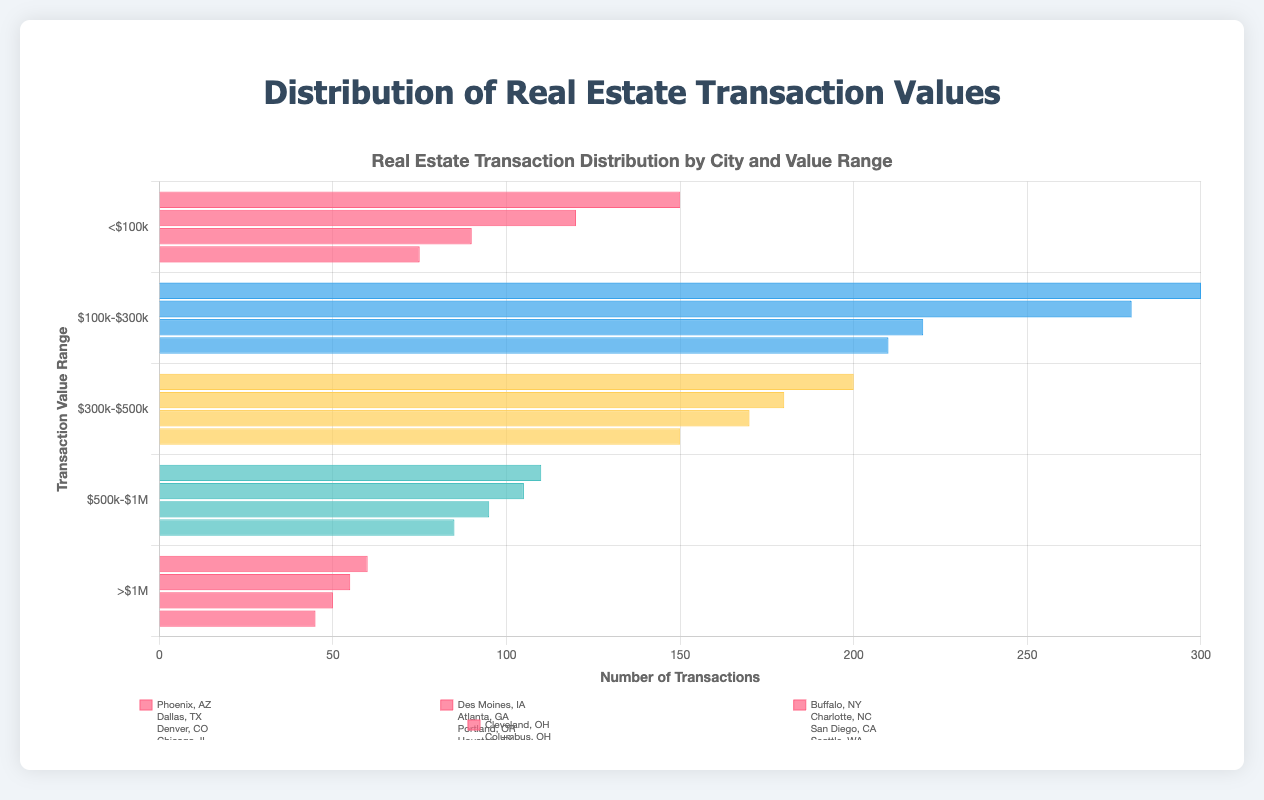Which city has the highest number of transactions in the <$100k range? Look at the first bar segment in each city category that corresponds to the <$100k range and identify the maximum height.
Answer: Phoenix What is the total number of transactions for cities in the $300k-$500k range? Sum the number of transactions for Denver, Portland, San Diego, and Miami in the $300k-$500k range: 200 + 180 + 170 + 150.
Answer: 700 Between Dallas and New York, which city has more transactions for their respective transaction ranges? Compare the count of transactions for Dallas ($100k-$300k) and New York (>$1M): Dallas has 300 and New York has 60. 300 is greater than 60.
Answer: Dallas Is the total number of transactions in San Francisco greater than the total transactions in Buffalo? Compare the sum of transactions for San Francisco in the >$1M range and Buffalo in the <$100k range. 55 (San Francisco) is less than 90 (Buffalo).
Answer: No How many more transactions does Dallas have compared to Columbus in the $100k-$300k range? Subtract the number of transactions in Columbus ($100k-$300k) from those in Dallas ($100k-$300k): 300 - 210.
Answer: 90 Which city has the fewest transactions in the $500k-$1M range? Identify the city with the smallest bar in the $500k-$1M category: Boston has the fewest transactions (85).
Answer: Boston What is the combined number of transactions for Portland and Miami in the $300k-$500k range? Add the transaction counts for Portland and Miami in the $300k-$500k range: 180 (Portland) + 150 (Miami).
Answer: 330 Are there more transactions in Houston or Seattle within the $500k-$1M range? Compare the transaction counts in the $500k-$1M range for Houston (105) and Seattle (95).
Answer: Houston Which city has more transactions below $100k, Des Moines or Cleveland? Compare the transactions for Des Moines (120) and Cleveland (75) in the <$100k range.
Answer: Des Moines What is the difference in transaction numbers between Charlotte and Columbus in the $100k-$300k range? Subtract the number of transactions for Columbus from Charlotte in the $100k-$300k range: 220 - 210.
Answer: 10 